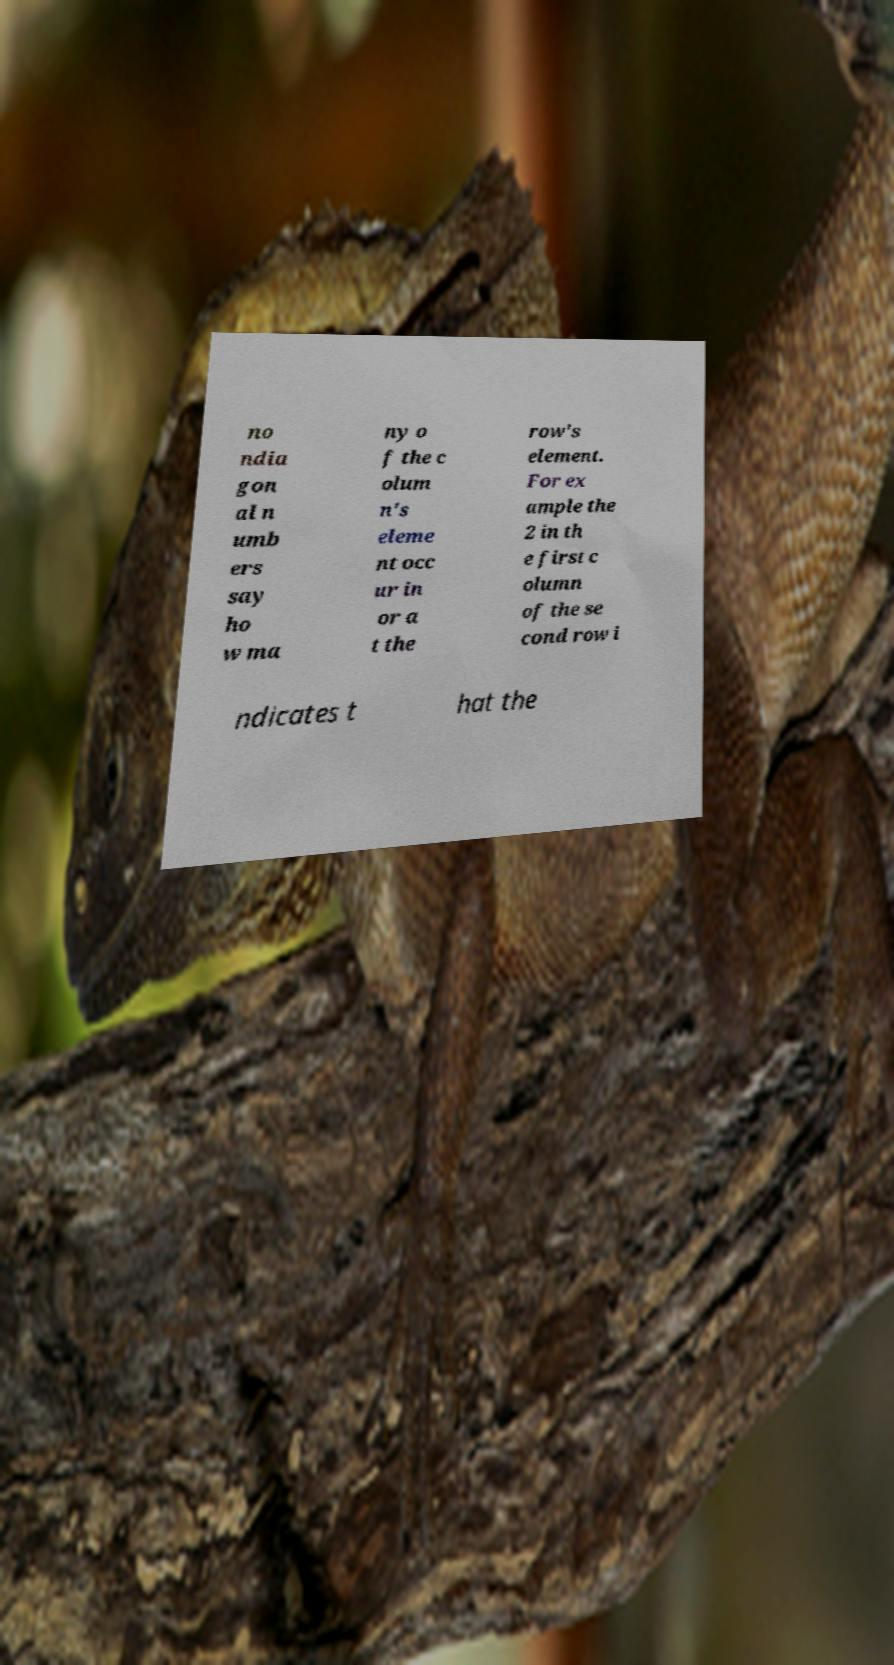Please read and relay the text visible in this image. What does it say? no ndia gon al n umb ers say ho w ma ny o f the c olum n's eleme nt occ ur in or a t the row's element. For ex ample the 2 in th e first c olumn of the se cond row i ndicates t hat the 